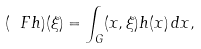Convert formula to latex. <formula><loc_0><loc_0><loc_500><loc_500>( \ F h ) ( \xi ) = \int _ { G } ( x , \xi ) h ( x ) \, d x ,</formula> 